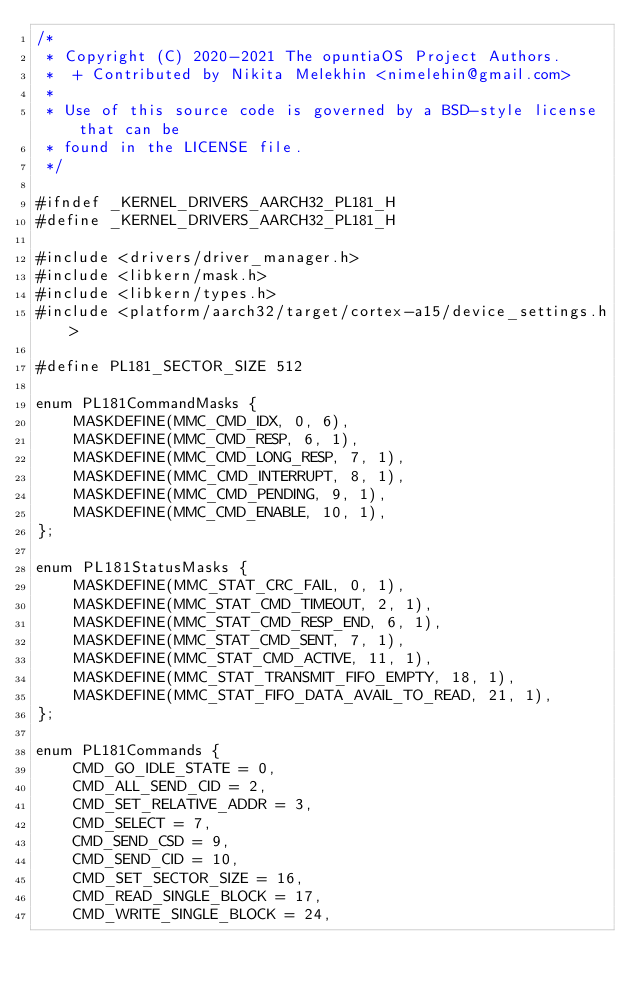<code> <loc_0><loc_0><loc_500><loc_500><_C_>/*
 * Copyright (C) 2020-2021 The opuntiaOS Project Authors.
 *  + Contributed by Nikita Melekhin <nimelehin@gmail.com>
 *
 * Use of this source code is governed by a BSD-style license that can be
 * found in the LICENSE file.
 */

#ifndef _KERNEL_DRIVERS_AARCH32_PL181_H
#define _KERNEL_DRIVERS_AARCH32_PL181_H

#include <drivers/driver_manager.h>
#include <libkern/mask.h>
#include <libkern/types.h>
#include <platform/aarch32/target/cortex-a15/device_settings.h>

#define PL181_SECTOR_SIZE 512

enum PL181CommandMasks {
    MASKDEFINE(MMC_CMD_IDX, 0, 6),
    MASKDEFINE(MMC_CMD_RESP, 6, 1),
    MASKDEFINE(MMC_CMD_LONG_RESP, 7, 1),
    MASKDEFINE(MMC_CMD_INTERRUPT, 8, 1),
    MASKDEFINE(MMC_CMD_PENDING, 9, 1),
    MASKDEFINE(MMC_CMD_ENABLE, 10, 1),
};

enum PL181StatusMasks {
    MASKDEFINE(MMC_STAT_CRC_FAIL, 0, 1),
    MASKDEFINE(MMC_STAT_CMD_TIMEOUT, 2, 1),
    MASKDEFINE(MMC_STAT_CMD_RESP_END, 6, 1),
    MASKDEFINE(MMC_STAT_CMD_SENT, 7, 1),
    MASKDEFINE(MMC_STAT_CMD_ACTIVE, 11, 1),
    MASKDEFINE(MMC_STAT_TRANSMIT_FIFO_EMPTY, 18, 1),
    MASKDEFINE(MMC_STAT_FIFO_DATA_AVAIL_TO_READ, 21, 1),
};

enum PL181Commands {
    CMD_GO_IDLE_STATE = 0,
    CMD_ALL_SEND_CID = 2,
    CMD_SET_RELATIVE_ADDR = 3,
    CMD_SELECT = 7,
    CMD_SEND_CSD = 9,
    CMD_SEND_CID = 10,
    CMD_SET_SECTOR_SIZE = 16,
    CMD_READ_SINGLE_BLOCK = 17,
    CMD_WRITE_SINGLE_BLOCK = 24,</code> 